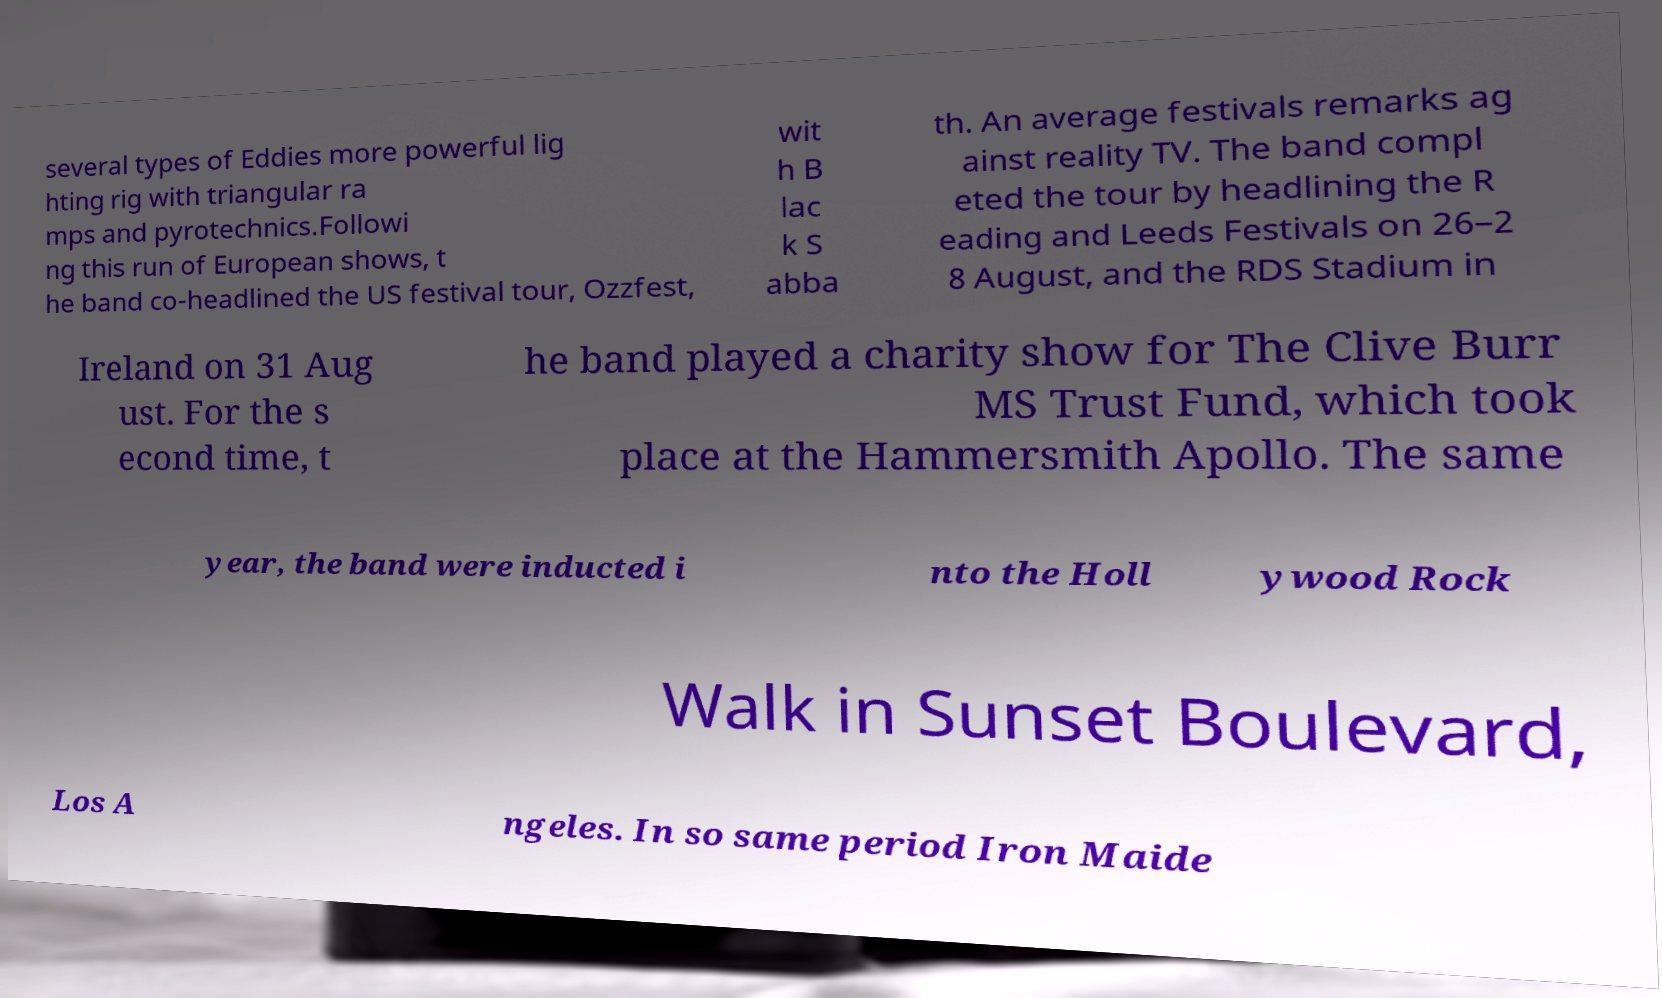Can you read and provide the text displayed in the image?This photo seems to have some interesting text. Can you extract and type it out for me? several types of Eddies more powerful lig hting rig with triangular ra mps and pyrotechnics.Followi ng this run of European shows, t he band co-headlined the US festival tour, Ozzfest, wit h B lac k S abba th. An average festivals remarks ag ainst reality TV. The band compl eted the tour by headlining the R eading and Leeds Festivals on 26–2 8 August, and the RDS Stadium in Ireland on 31 Aug ust. For the s econd time, t he band played a charity show for The Clive Burr MS Trust Fund, which took place at the Hammersmith Apollo. The same year, the band were inducted i nto the Holl ywood Rock Walk in Sunset Boulevard, Los A ngeles. In so same period Iron Maide 